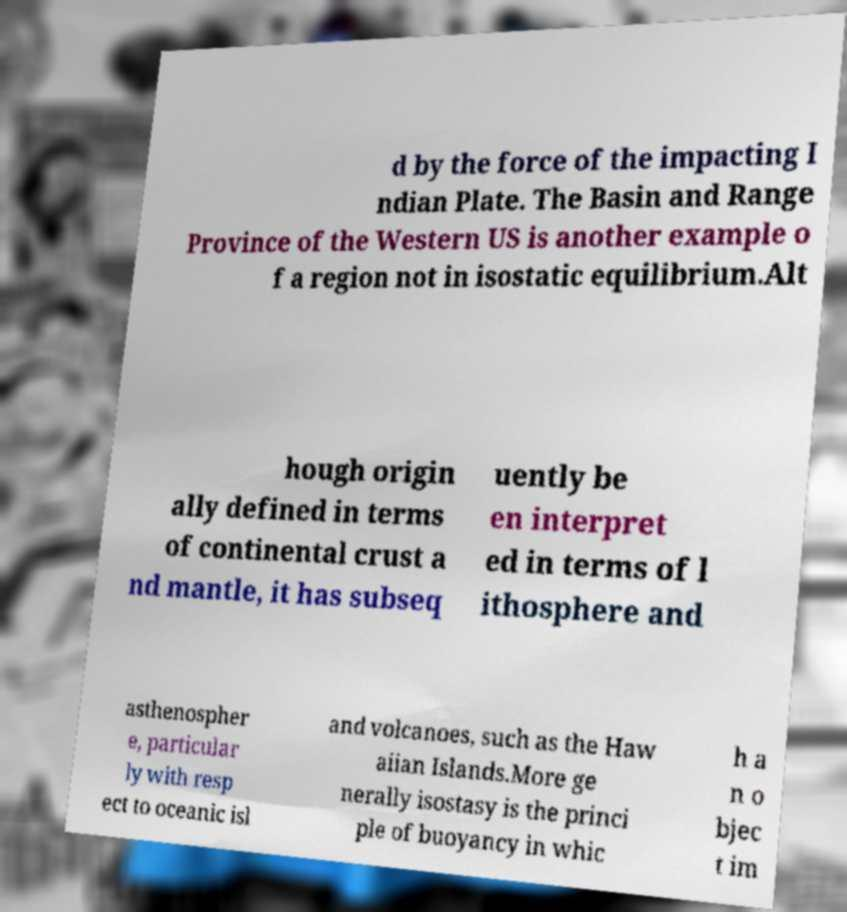What messages or text are displayed in this image? I need them in a readable, typed format. d by the force of the impacting I ndian Plate. The Basin and Range Province of the Western US is another example o f a region not in isostatic equilibrium.Alt hough origin ally defined in terms of continental crust a nd mantle, it has subseq uently be en interpret ed in terms of l ithosphere and asthenospher e, particular ly with resp ect to oceanic isl and volcanoes, such as the Haw aiian Islands.More ge nerally isostasy is the princi ple of buoyancy in whic h a n o bjec t im 